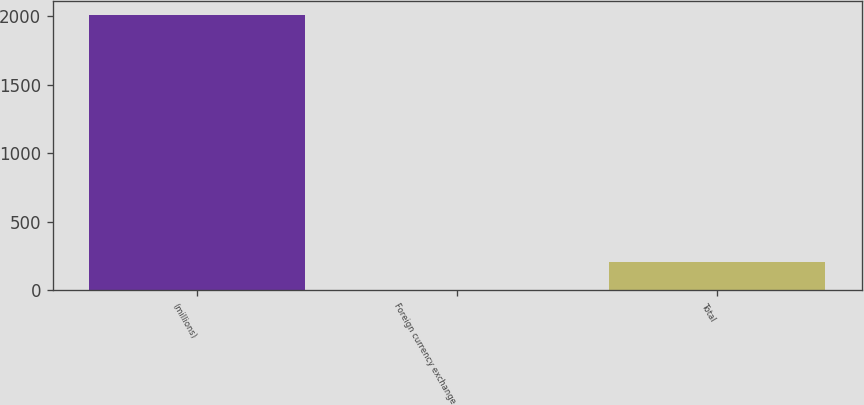Convert chart to OTSL. <chart><loc_0><loc_0><loc_500><loc_500><bar_chart><fcel>(millions)<fcel>Foreign currency exchange<fcel>Total<nl><fcel>2012<fcel>5<fcel>205.7<nl></chart> 